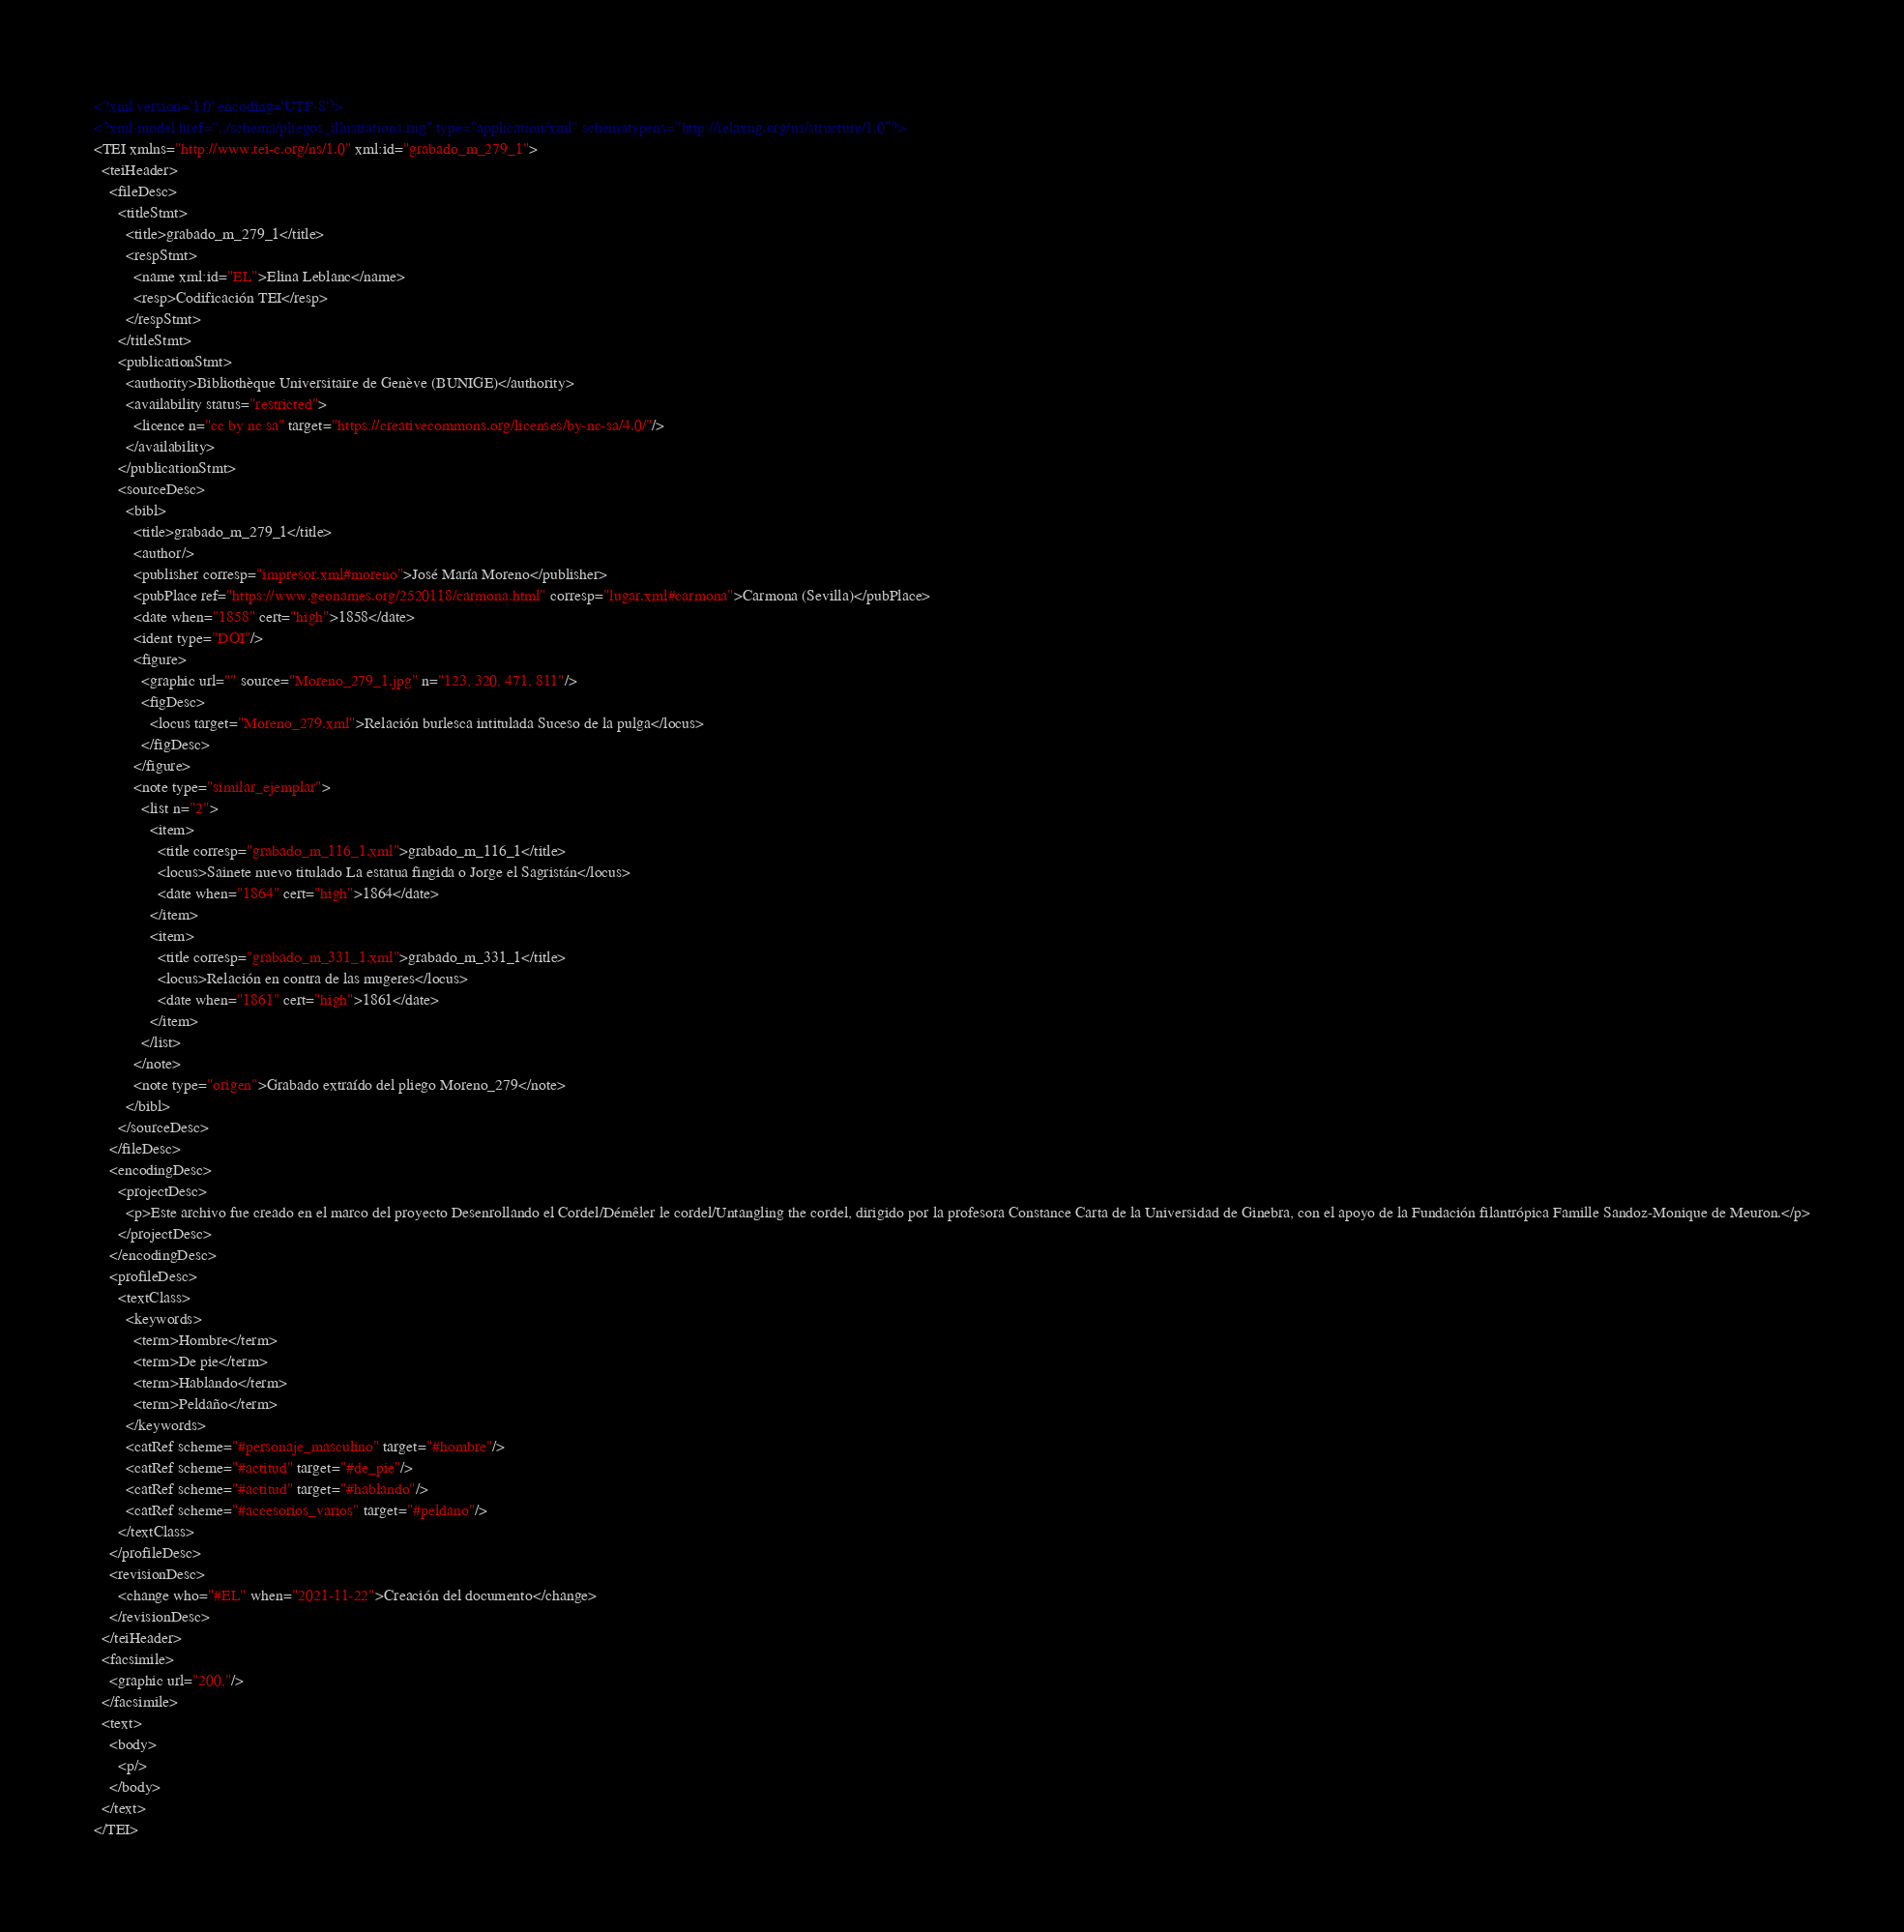<code> <loc_0><loc_0><loc_500><loc_500><_XML_><?xml version='1.0' encoding='UTF-8'?>
<?xml-model href="../schema/pliegos_illustrations.rng" type="application/xml" schematypens="http://relaxng.org/ns/structure/1.0"?>
<TEI xmlns="http://www.tei-c.org/ns/1.0" xml:id="grabado_m_279_1">
  <teiHeader>
    <fileDesc>
      <titleStmt>
        <title>grabado_m_279_1</title>
        <respStmt>
          <name xml:id="EL">Elina Leblanc</name>
          <resp>Codificación TEI</resp>
        </respStmt>
      </titleStmt>
      <publicationStmt>
        <authority>Bibliothèque Universitaire de Genève (BUNIGE)</authority>
        <availability status="restricted">
          <licence n="cc by nc sa" target="https://creativecommons.org/licenses/by-nc-sa/4.0/"/>
        </availability>
      </publicationStmt>
      <sourceDesc>
        <bibl>
          <title>grabado_m_279_1</title>
          <author/>
          <publisher corresp="impresor.xml#moreno">José María Moreno</publisher>
          <pubPlace ref="https://www.geonames.org/2520118/carmona.html" corresp="lugar.xml#carmona">Carmona (Sevilla)</pubPlace>
          <date when="1858" cert="high">1858</date>
          <ident type="DOI"/>
          <figure>
            <graphic url="" source="Moreno_279_1.jpg" n="123, 320, 471, 811"/>
            <figDesc>
              <locus target="Moreno_279.xml">Relación burlesca intitulada Suceso de la pulga</locus>
            </figDesc>
          </figure>
          <note type="similar_ejemplar">
            <list n="2">
              <item>
                <title corresp="grabado_m_116_1.xml">grabado_m_116_1</title>
                <locus>Sainete nuevo titulado La estatua fingida o Jorge el Sagristán</locus>
                <date when="1864" cert="high">1864</date>
              </item>
              <item>
                <title corresp="grabado_m_331_1.xml">grabado_m_331_1</title>
                <locus>Relación en contra de las mugeres</locus>
                <date when="1861" cert="high">1861</date>
              </item>
            </list>
          </note>
          <note type="origen">Grabado extraído del pliego Moreno_279</note>
        </bibl>
      </sourceDesc>
    </fileDesc>
    <encodingDesc>
      <projectDesc>
        <p>Este archivo fue creado en el marco del proyecto Desenrollando el Cordel/Démêler le cordel/Untangling the cordel, dirigido por la profesora Constance Carta de la Universidad de Ginebra, con el apoyo de la Fundación filantrópica Famille Sandoz-Monique de Meuron.</p>
      </projectDesc>
    </encodingDesc>
    <profileDesc>
      <textClass>
        <keywords>
          <term>Hombre</term>
          <term>De pie</term>
          <term>Hablando</term>
          <term>Peldaño</term>
        </keywords>
        <catRef scheme="#personaje_masculino" target="#hombre"/>
        <catRef scheme="#actitud" target="#de_pie"/>
        <catRef scheme="#actitud" target="#hablando"/>
        <catRef scheme="#accesorios_varios" target="#peldano"/>
      </textClass>
    </profileDesc>
    <revisionDesc>
      <change who="#EL" when="2021-11-22">Creación del documento</change>
    </revisionDesc>
  </teiHeader>
  <facsimile>
    <graphic url="200,"/>
  </facsimile>
  <text>
    <body>
      <p/>
    </body>
  </text>
</TEI></code> 